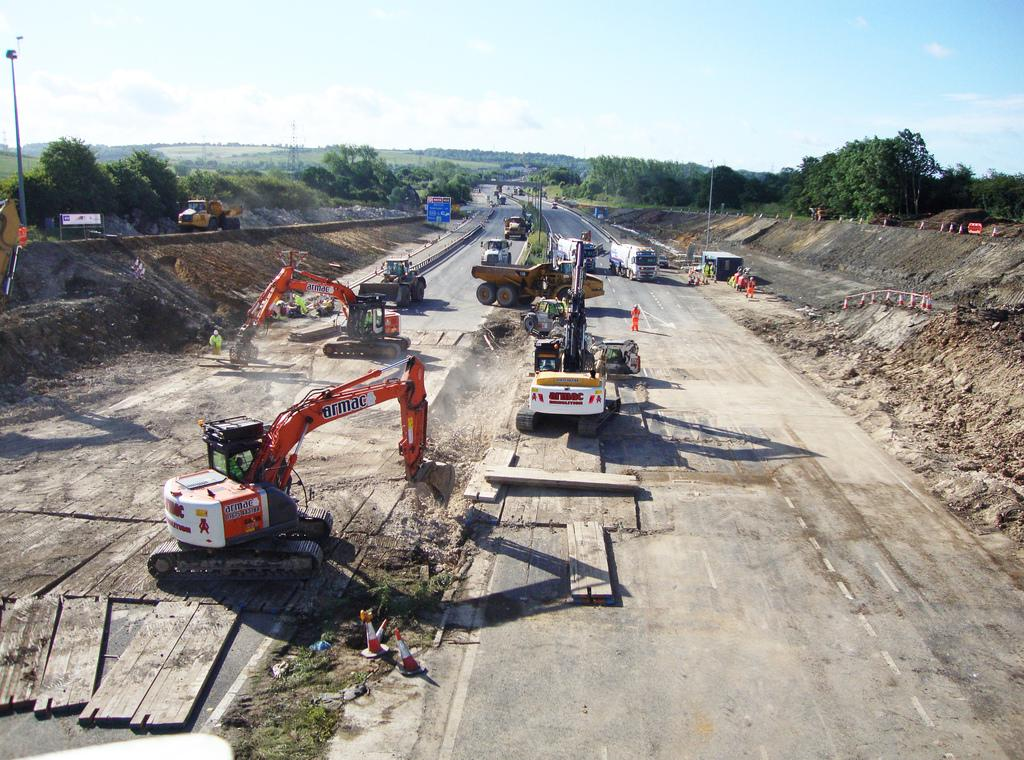<image>
Provide a brief description of the given image. Large orange and white vehicle that says "ARMAC" on it. 